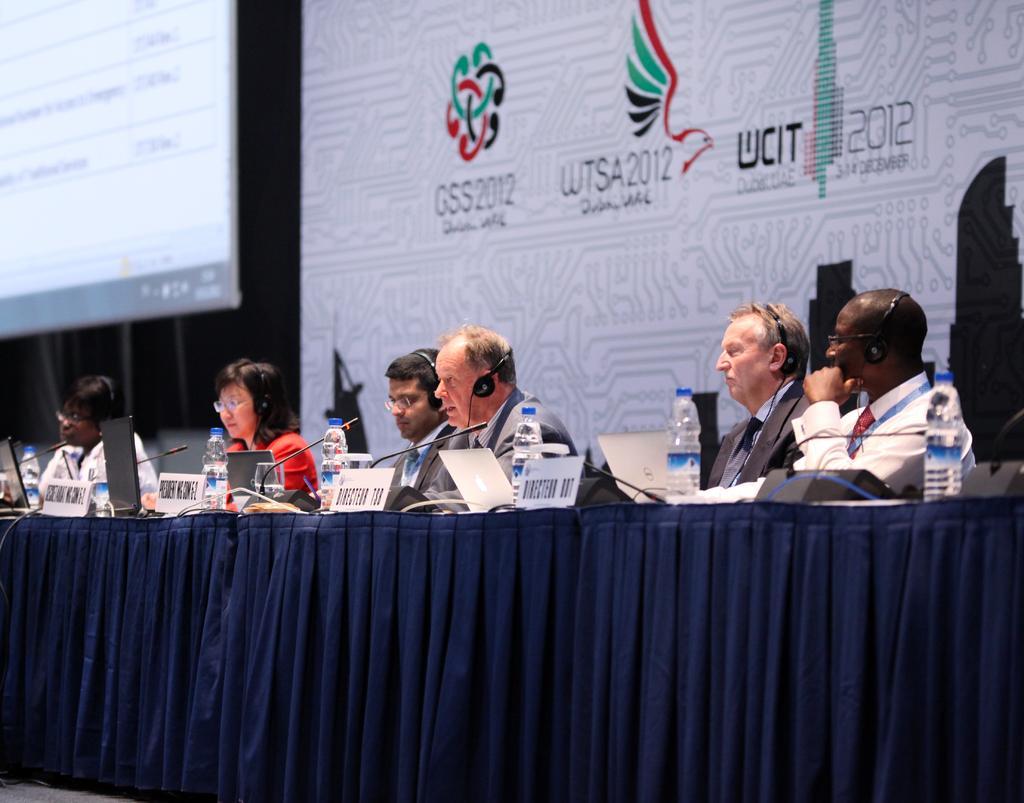Could you give a brief overview of what you see in this image? There are persons in different color dresses sitting in front of a table which is covered with violet color cloth, on which there are bottles, name boards, mics and laptops. In the background, there is a hoarding and there is a screen. 